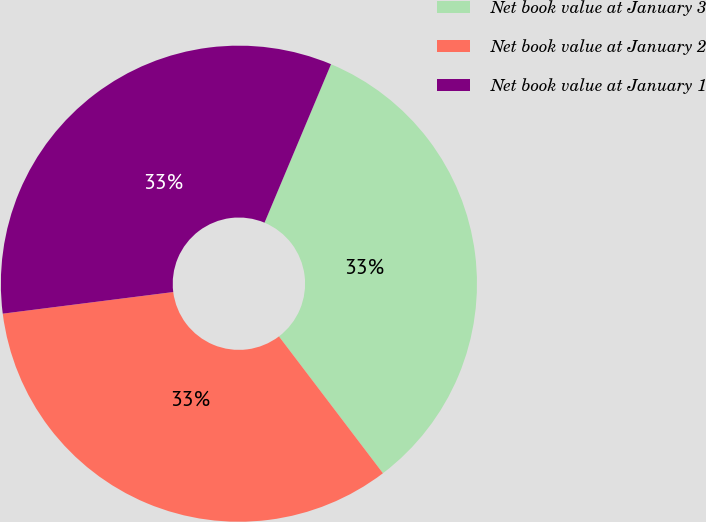<chart> <loc_0><loc_0><loc_500><loc_500><pie_chart><fcel>Net book value at January 3<fcel>Net book value at January 2<fcel>Net book value at January 1<nl><fcel>33.33%<fcel>33.33%<fcel>33.33%<nl></chart> 